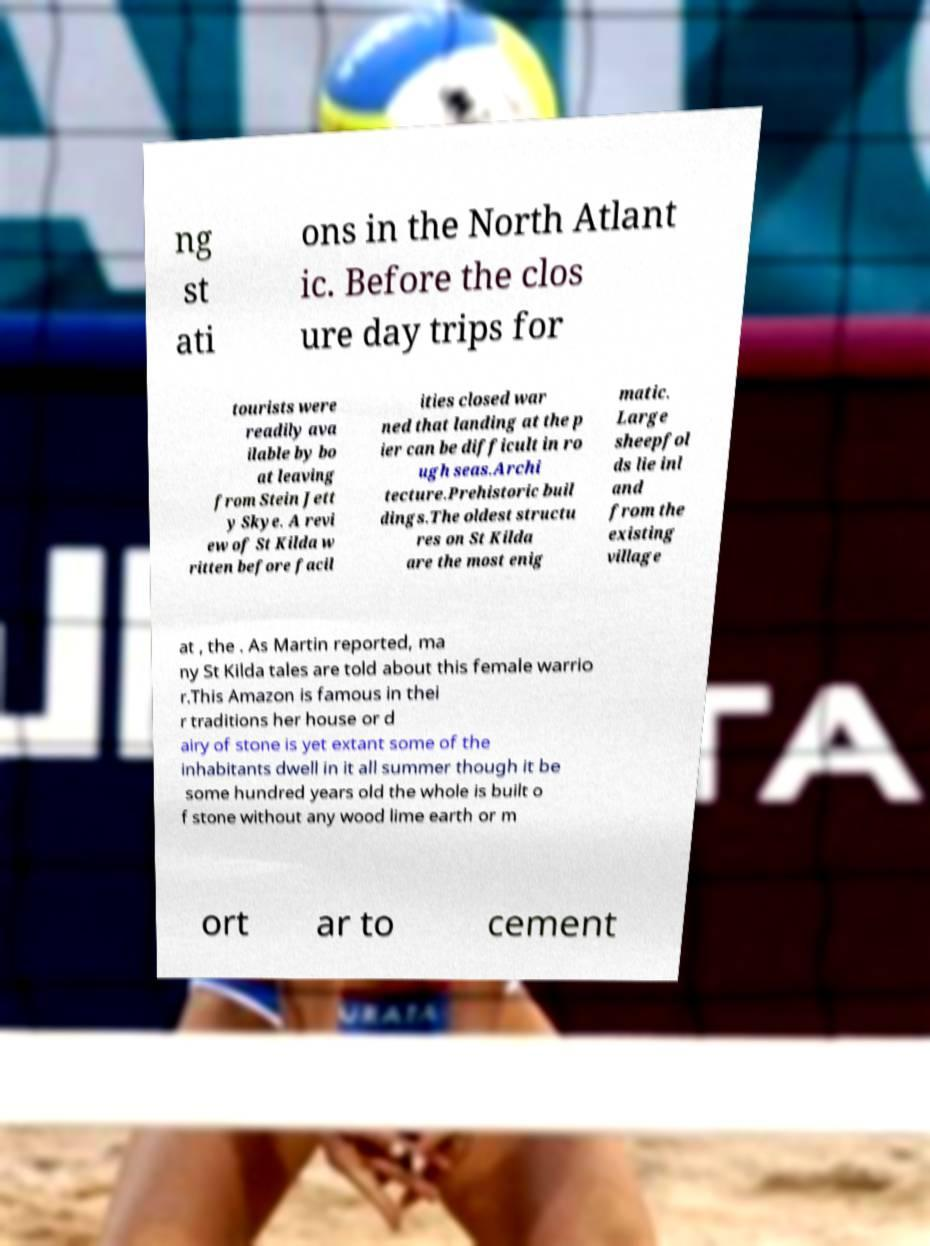Can you read and provide the text displayed in the image?This photo seems to have some interesting text. Can you extract and type it out for me? ng st ati ons in the North Atlant ic. Before the clos ure day trips for tourists were readily ava ilable by bo at leaving from Stein Jett y Skye. A revi ew of St Kilda w ritten before facil ities closed war ned that landing at the p ier can be difficult in ro ugh seas.Archi tecture.Prehistoric buil dings.The oldest structu res on St Kilda are the most enig matic. Large sheepfol ds lie inl and from the existing village at , the . As Martin reported, ma ny St Kilda tales are told about this female warrio r.This Amazon is famous in thei r traditions her house or d airy of stone is yet extant some of the inhabitants dwell in it all summer though it be some hundred years old the whole is built o f stone without any wood lime earth or m ort ar to cement 